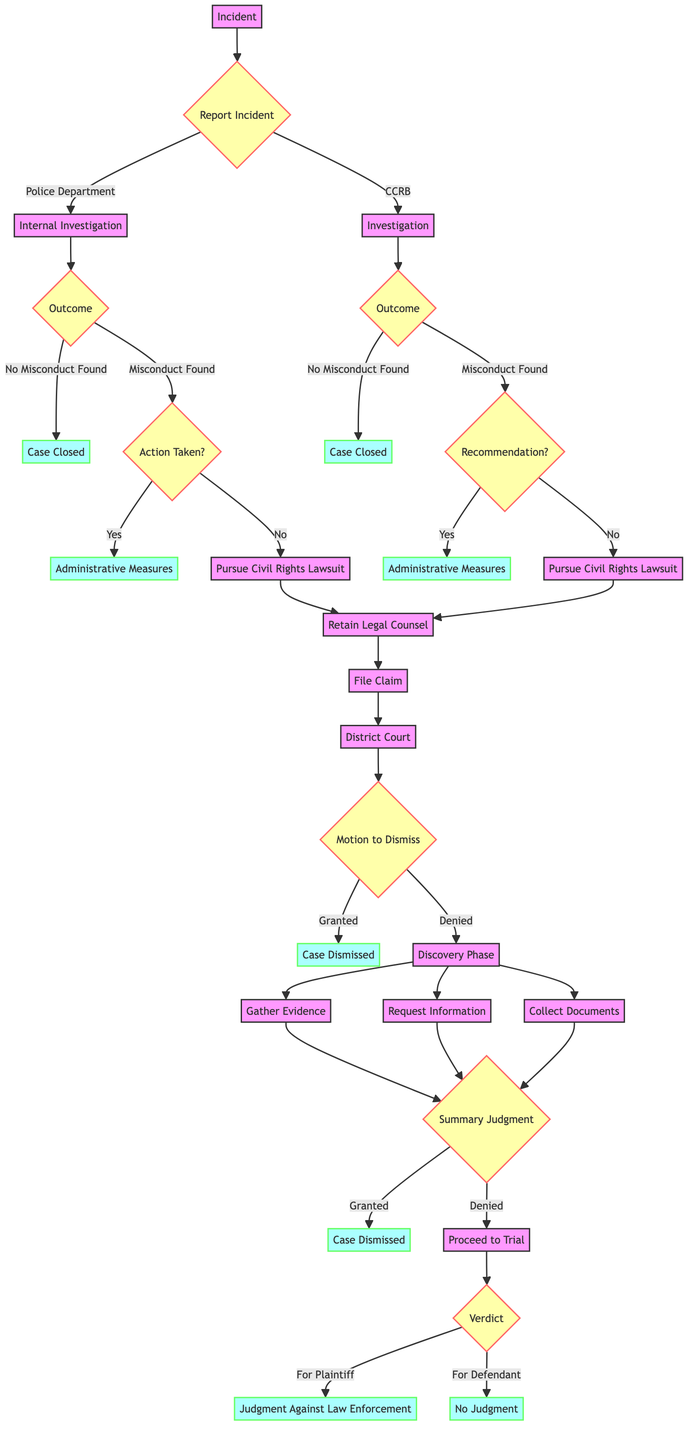What is the first step after the incident in the decision tree? The first step after the incident is to "Report Incident," which branches into two possibilities: reporting to the Police Department or the Civilian Complaint Review Board.
Answer: Report Incident How many outcomes are there after the Internal Investigation? The Internal Investigation has two possible outcomes: "No Misconduct Found" and "Misconduct Found," resulting in a total of two outcomes.
Answer: 2 What happens if "Misconduct Found" and "No Action Taken" during the Internal Investigation? In this case, the next step is to "Pursue Civil Rights Lawsuit," indicating that the plaintiff will seek legal recourse due to lack of accountability.
Answer: Pursue Civil Rights Lawsuit If a case is dismissed at the "Motion to Dismiss" step, what is the status of the case? If the "Motion to Dismiss" is granted, the status of the case becomes "Case Dismissed," meaning the lawsuit will not proceed further in court.
Answer: Case Dismissed What are the three actions taken during the Discovery Phase? During the Discovery Phase, the three actions taken are "Gather Evidence," "Request Information," and "Collect Documents." These steps are crucial for building the case.
Answer: Gather Evidence, Request Information, Collect Documents What must occur after a "Summary Judgment Motion" is denied? If the "Summary Judgment Motion" is denied, the case proceeds to "Trial," where it will be formally heard and a verdict will be issued.
Answer: Proceed to Trial What two potential verdicts can be reached at the Trial stage? The two potential verdicts at the Trial stage are "In Favor of Plaintiff" and "In Favor of Defendant," leading to different outcomes based on the decision.
Answer: In Favor of Plaintiff, In Favor of Defendant What recommendations occur if "Misconduct Found" in the CCRB investigation? If misconduct is found in the CCRB investigation, there is a recommendation for "Disciplinary Action," which could lead to administrative measures being taken against the law enforcement personnel involved.
Answer: Administrative Measures If a civilian chooses to report the incident to the CCRB, what are the resulting steps from there? After reporting to the CCRB, the steps include conducting an "Investigation," leading to outcomes of either "No Misconduct Found" or recommendations for further action, including possibly pursuing a lawsuit.
Answer: Investigation 